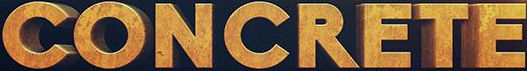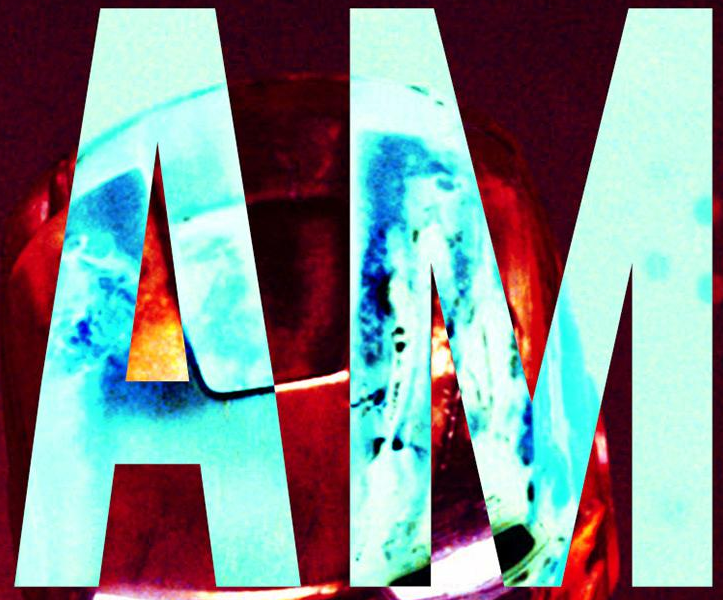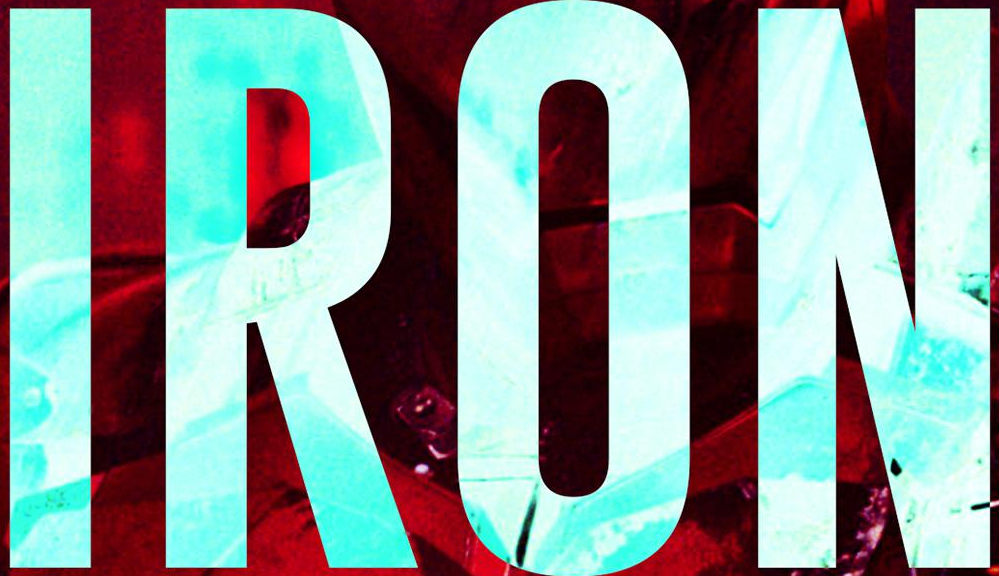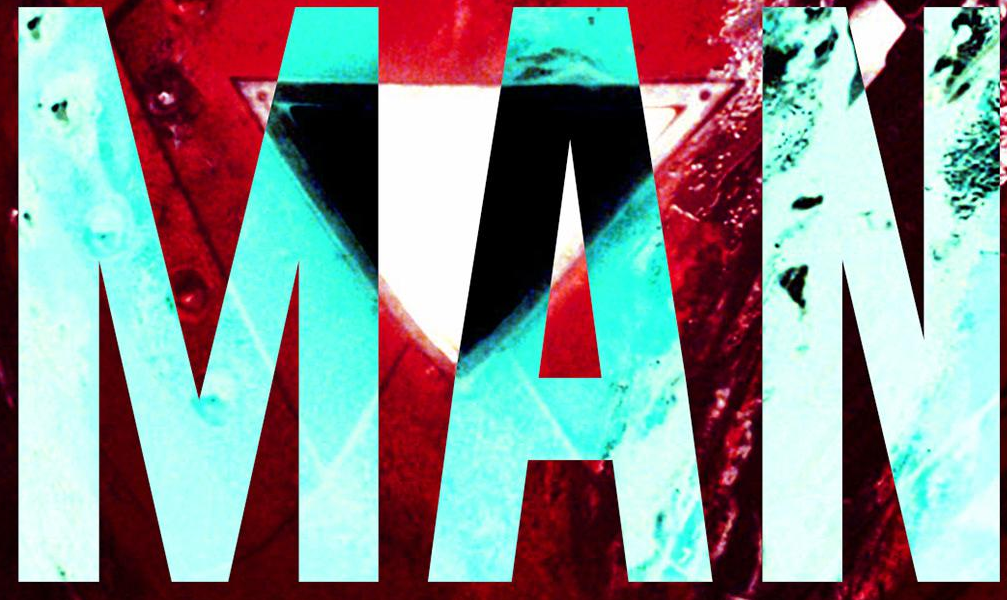What text appears in these images from left to right, separated by a semicolon? CONCRETE; AM; IRON; MAN 